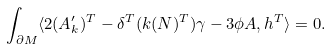<formula> <loc_0><loc_0><loc_500><loc_500>\int _ { \partial M } \langle 2 ( A _ { k } ^ { \prime } ) ^ { T } - \delta ^ { T } ( k ( N ) ^ { T } ) \gamma - 3 \phi A , h ^ { T } \rangle = 0 .</formula> 